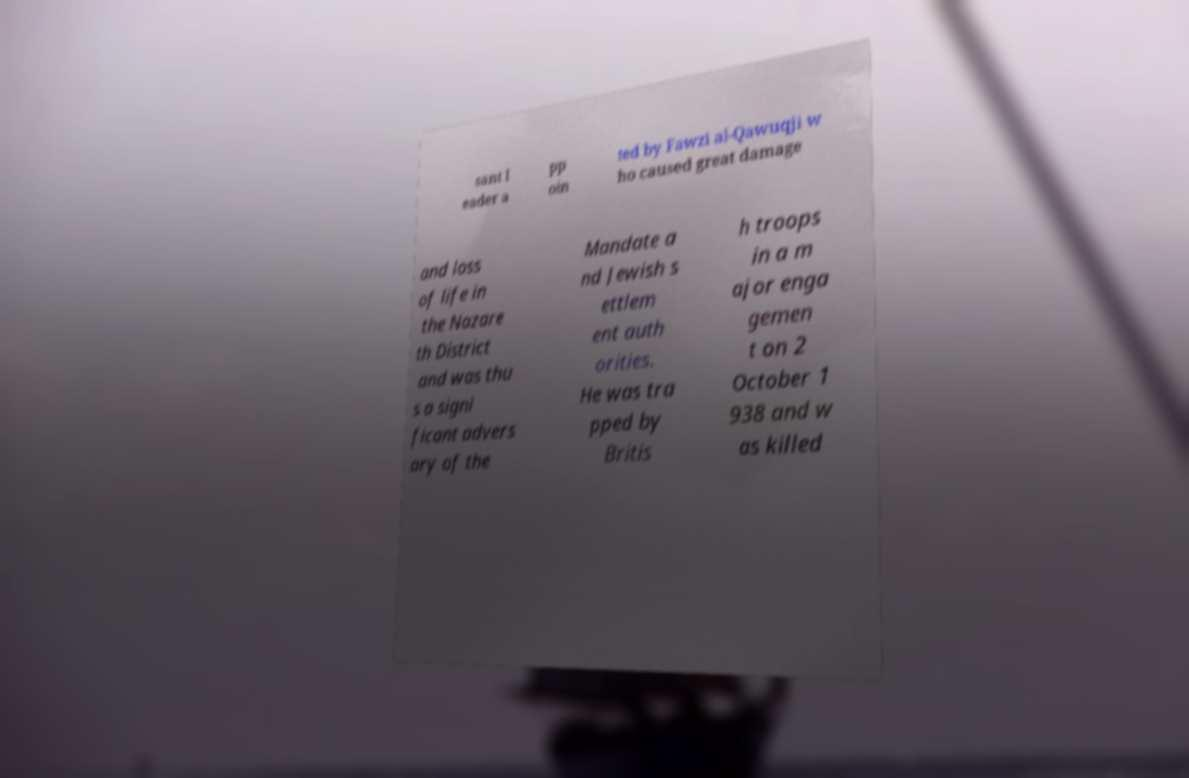Please read and relay the text visible in this image. What does it say? sant l eader a pp oin ted by Fawzi al-Qawuqji w ho caused great damage and loss of life in the Nazare th District and was thu s a signi ficant advers ary of the Mandate a nd Jewish s ettlem ent auth orities. He was tra pped by Britis h troops in a m ajor enga gemen t on 2 October 1 938 and w as killed 